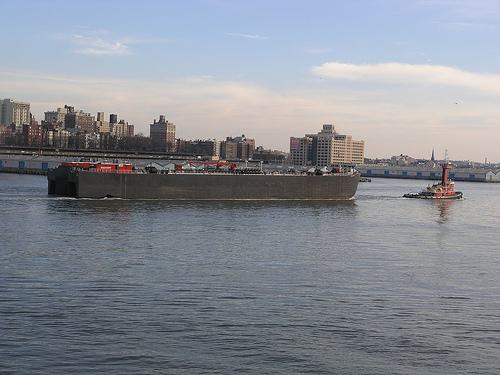Can you describe the weather conditions in the photo? The sky is mostly clear with a few scattered clouds, indicating fair weather conditions. The visibility is good, as the buildings across the water are quite discernible. What might be the function of the two boats? The barge is likely used for transporting heavy goods, possibly raw materials, given its large, flat structure. The smaller boat is a tugboat, which is used to maneuver vessels that cannot move themselves within harbors or narrow waterways. 